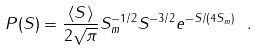Convert formula to latex. <formula><loc_0><loc_0><loc_500><loc_500>P ( S ) = \frac { \langle S \rangle } { 2 \sqrt { \pi } } S _ { m } ^ { - 1 / 2 } S ^ { - 3 / 2 } e ^ { - S / ( 4 S _ { m } ) } \ .</formula> 